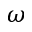<formula> <loc_0><loc_0><loc_500><loc_500>\omega</formula> 